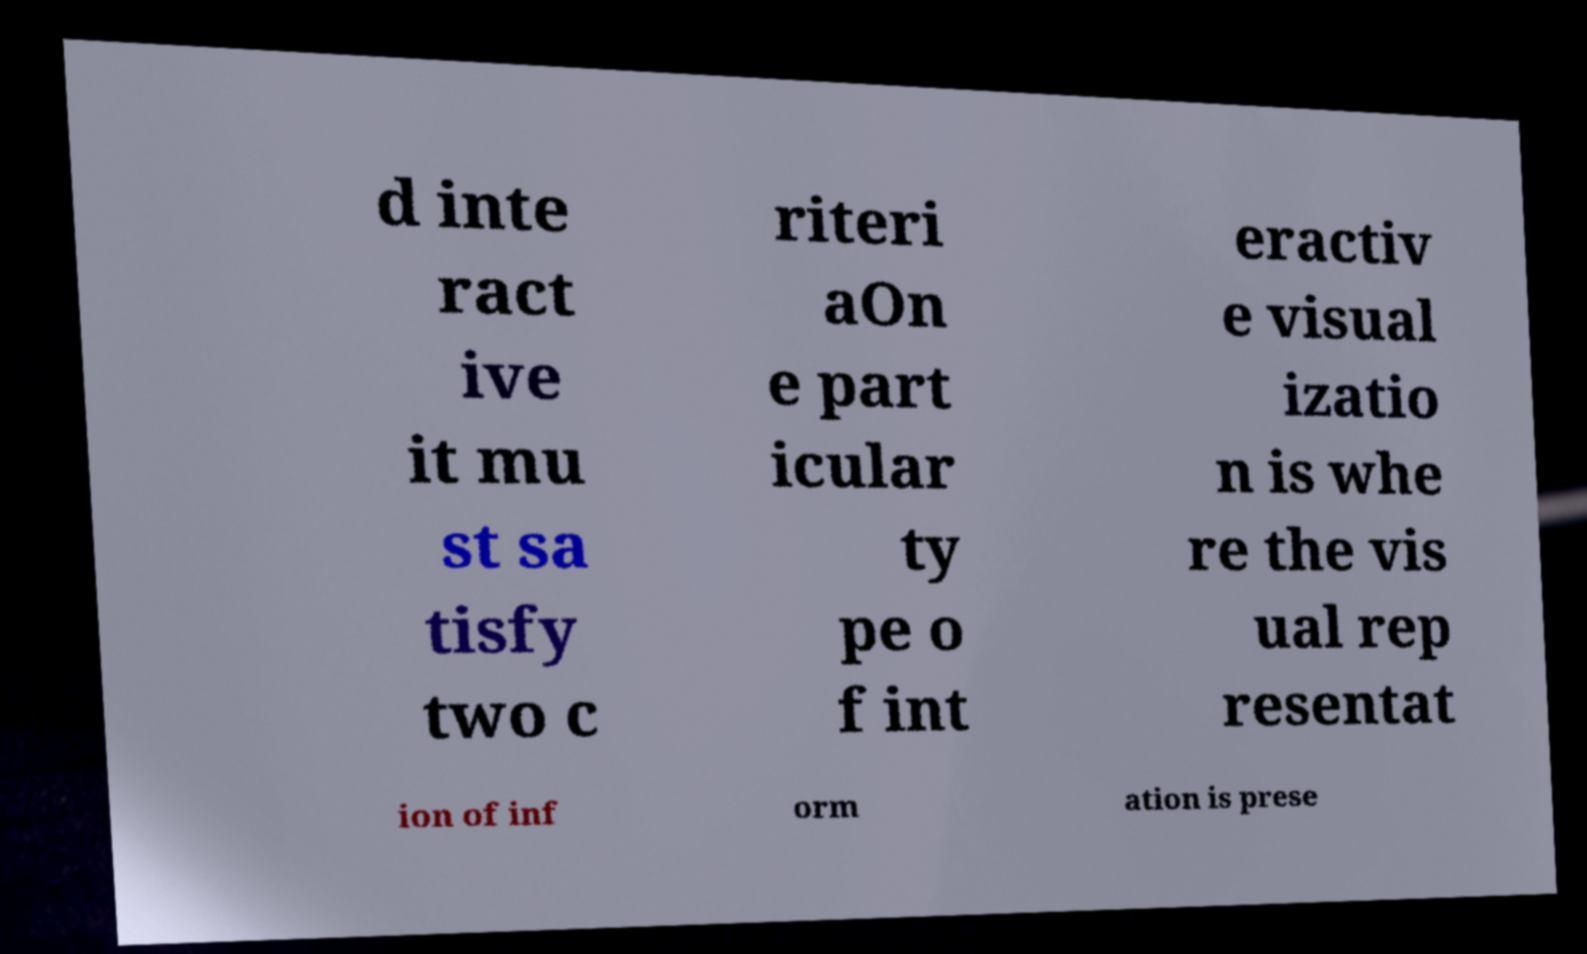Can you read and provide the text displayed in the image?This photo seems to have some interesting text. Can you extract and type it out for me? d inte ract ive it mu st sa tisfy two c riteri aOn e part icular ty pe o f int eractiv e visual izatio n is whe re the vis ual rep resentat ion of inf orm ation is prese 